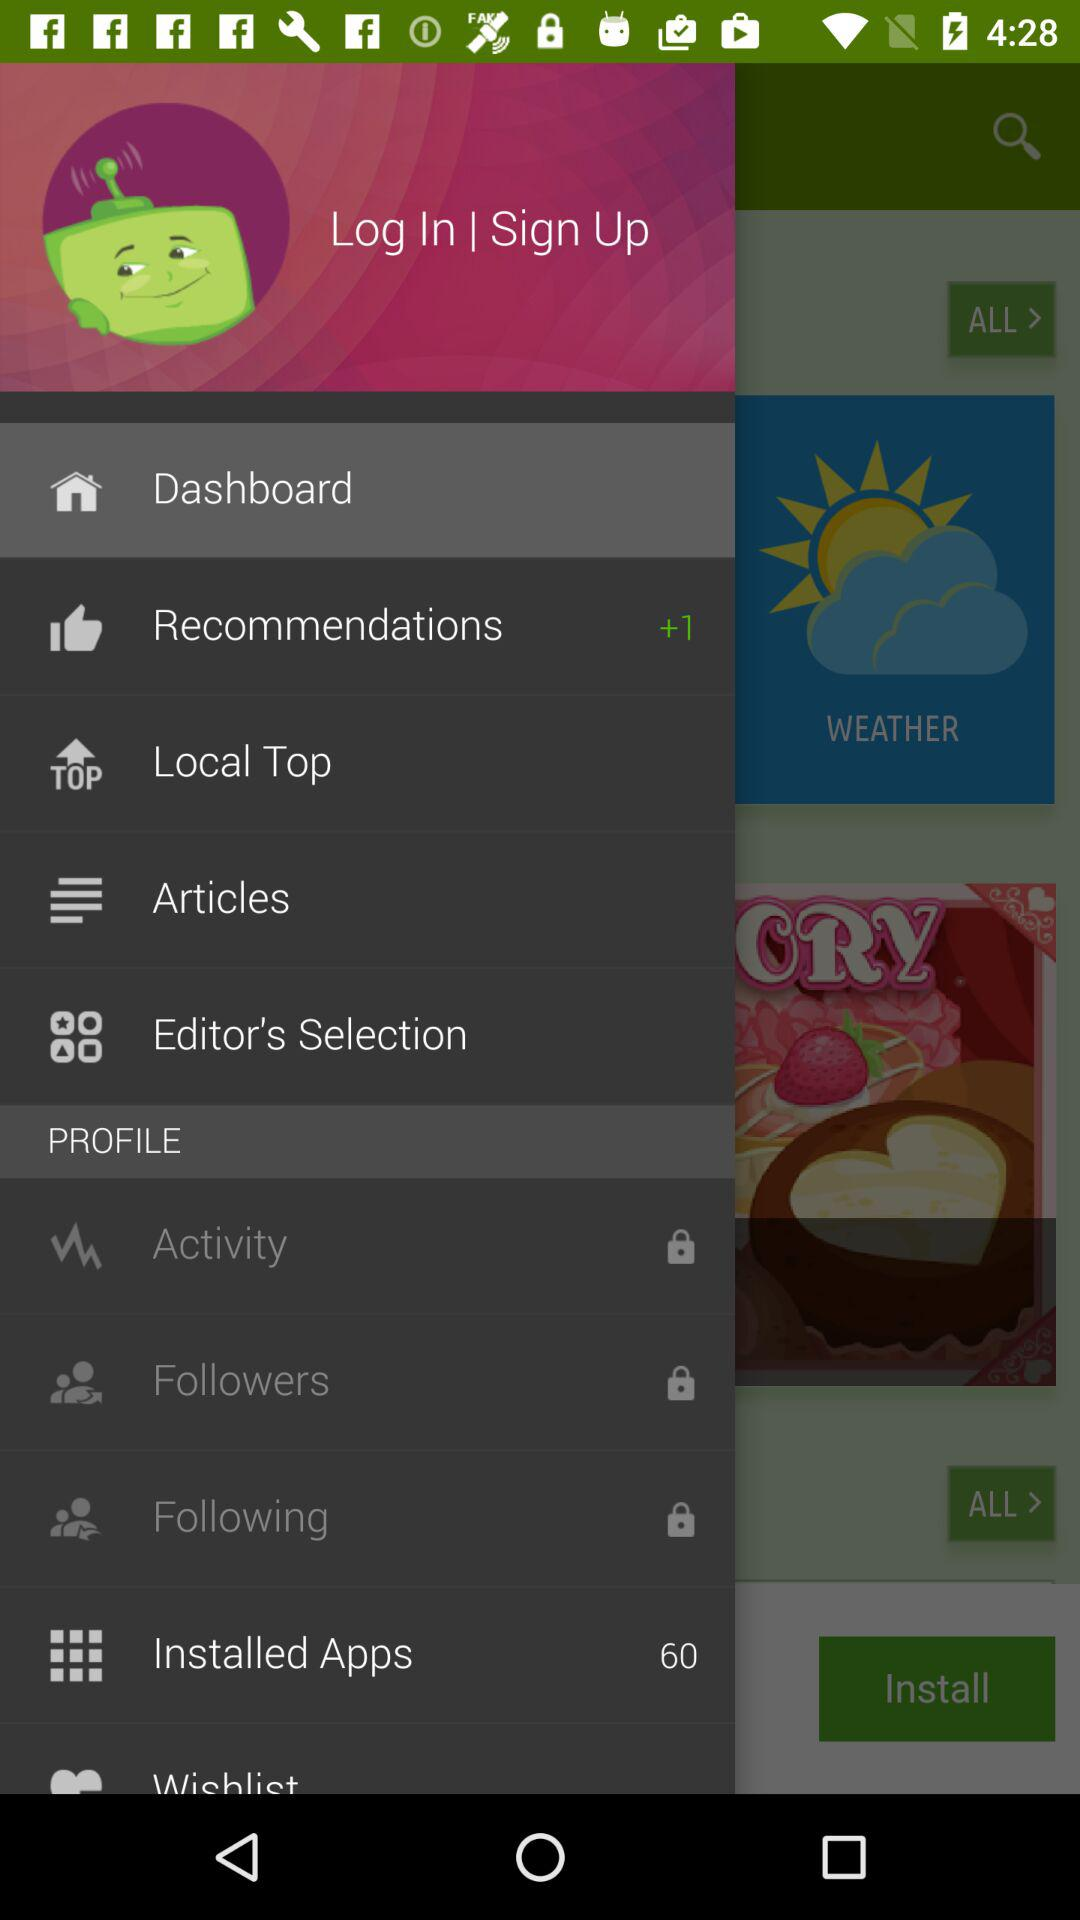Which articles are listed?
When the provided information is insufficient, respond with <no answer>. <no answer> 